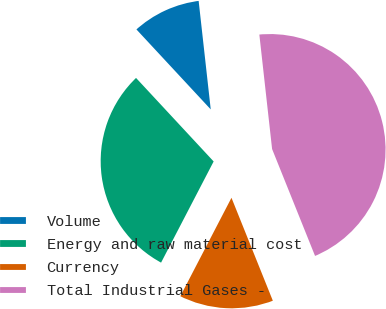Convert chart. <chart><loc_0><loc_0><loc_500><loc_500><pie_chart><fcel>Volume<fcel>Energy and raw material cost<fcel>Currency<fcel>Total Industrial Gases -<nl><fcel>10.15%<fcel>30.46%<fcel>13.71%<fcel>45.69%<nl></chart> 